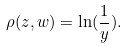Convert formula to latex. <formula><loc_0><loc_0><loc_500><loc_500>\rho ( z , w ) = \ln ( \frac { 1 } { y } ) .</formula> 